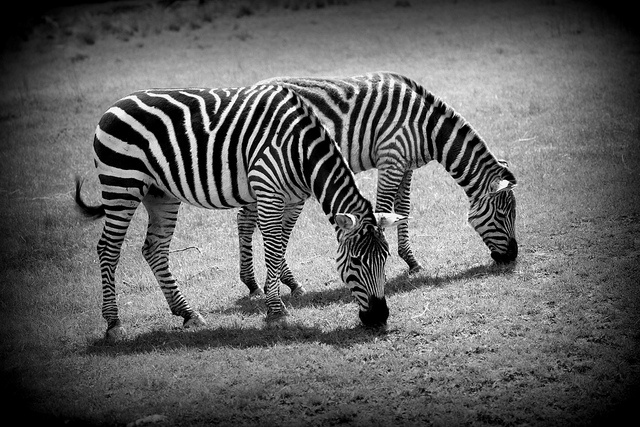Describe the objects in this image and their specific colors. I can see zebra in black, darkgray, gray, and lightgray tones and zebra in black, darkgray, gray, and lightgray tones in this image. 